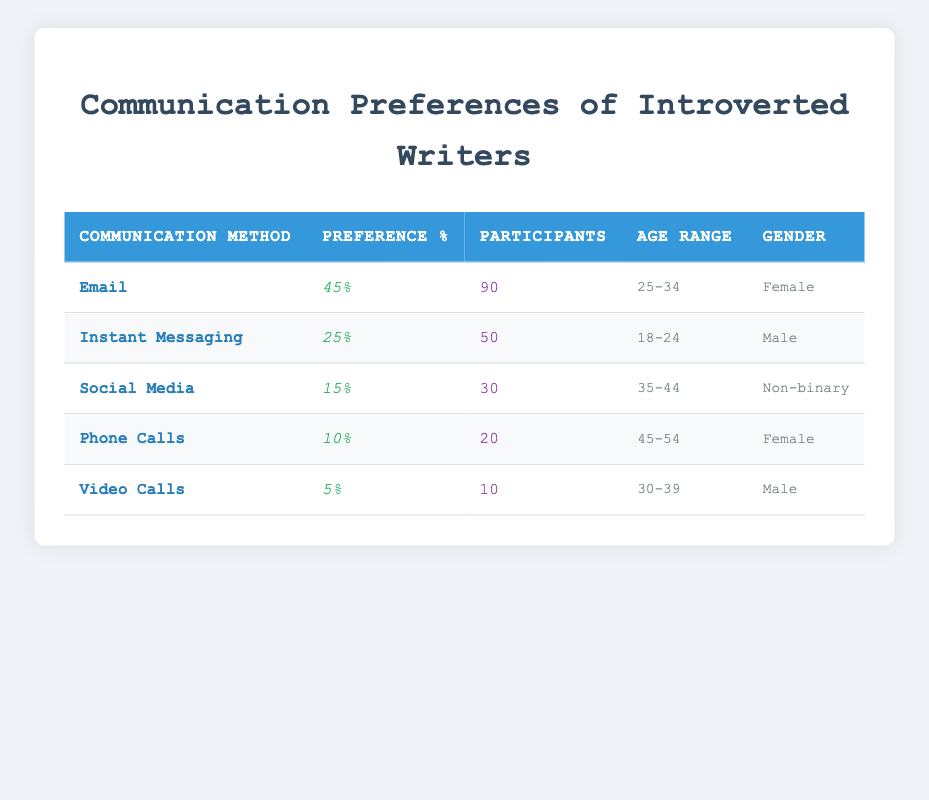What is the preferred communication method among introverted writers? Referring to the table, "Email" has the highest preference percentage at 45%.
Answer: Email How many participants prefer "Instant Messaging"? The table directly indicates that 50 participants prefer "Instant Messaging".
Answer: 50 What percentage of participants prefer "Social Media"? According to the table, "Social Media" has a preference percentage of 15%.
Answer: 15% Is there a higher preference for phone calls compared to video calls? The preference percentage for Phone Calls is 10%, and for Video Calls, it is 5%. Since 10% is greater than 5%, the answer is yes.
Answer: Yes What is the total percentage preference for communication methods among introverted writers? Adding the percentages: 45% (Email) + 25% (Instant Messaging) + 15% (Social Media) + 10% (Phone Calls) + 5% (Video Calls) gives a total of 100%. Therefore, the total is 100%.
Answer: 100% Which gender has the highest number of participants in the survey? The table shows 90 female participants (Email), 50 male participants (Instant Messaging), and 30 non-binary participants (Social Media). 90 is the highest, so it is female.
Answer: Female What age range has the lowest preference percentage, and what is that percentage? Video Calls have the lowest preference at 5%, and the age range for this group is 30-39. Hence, it is the 30-39 age range with 5%.
Answer: 30-39, 5% What is the average preference percentage for all communication methods? To find the average, sum the percentages: (45 + 25 + 15 + 10 + 5) = 100%. Divide by the number of methods (5): 100% / 5 = 20%.
Answer: 20% Have any non-binary participants indicated a preference for phone calls? The table shows that non-binary participants prefer "Social Media" with a preference of 15%. Since there are no non-binary respondents listed for phone calls, the answer is no.
Answer: No 